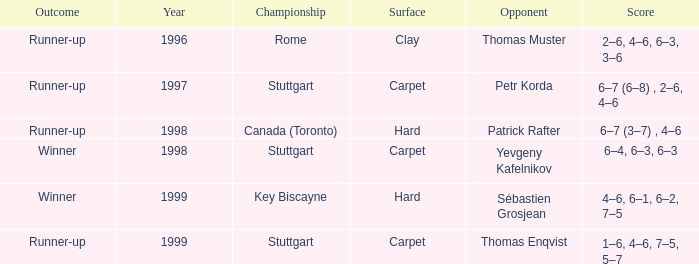What championship after 1997 was the score 1–6, 4–6, 7–5, 5–7? Stuttgart. 